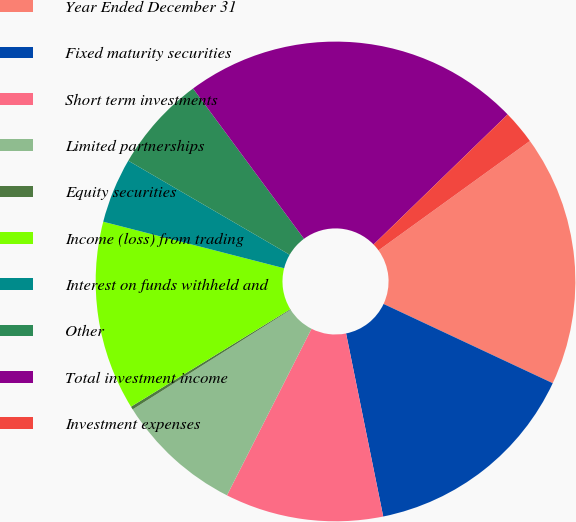Convert chart to OTSL. <chart><loc_0><loc_0><loc_500><loc_500><pie_chart><fcel>Year Ended December 31<fcel>Fixed maturity securities<fcel>Short term investments<fcel>Limited partnerships<fcel>Equity securities<fcel>Income (loss) from trading<fcel>Interest on funds withheld and<fcel>Other<fcel>Total investment income<fcel>Investment expenses<nl><fcel>16.93%<fcel>14.84%<fcel>10.66%<fcel>8.57%<fcel>0.21%<fcel>12.75%<fcel>4.39%<fcel>6.48%<fcel>22.86%<fcel>2.3%<nl></chart> 